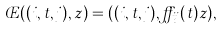<formula> <loc_0><loc_0><loc_500><loc_500>\phi ( ( i , t , j ) , z ) = ( ( i , t , j ) , \alpha _ { i j } ( t ) z ) ,</formula> 